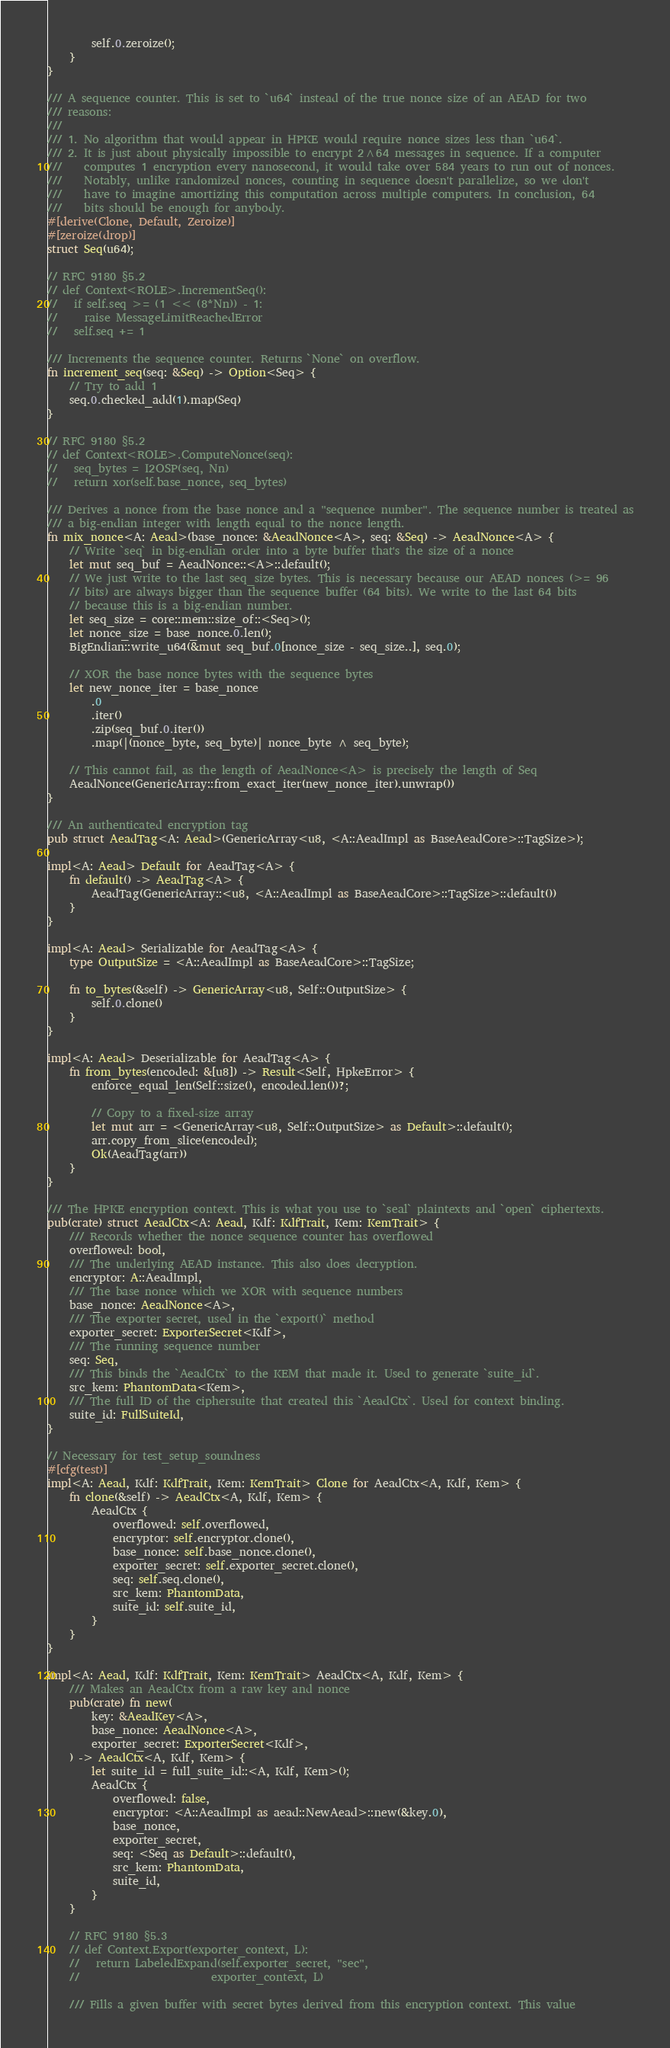<code> <loc_0><loc_0><loc_500><loc_500><_Rust_>        self.0.zeroize();
    }
}

/// A sequence counter. This is set to `u64` instead of the true nonce size of an AEAD for two
/// reasons:
///
/// 1. No algorithm that would appear in HPKE would require nonce sizes less than `u64`.
/// 2. It is just about physically impossible to encrypt 2^64 messages in sequence. If a computer
///    computes 1 encryption every nanosecond, it would take over 584 years to run out of nonces.
///    Notably, unlike randomized nonces, counting in sequence doesn't parallelize, so we don't
///    have to imagine amortizing this computation across multiple computers. In conclusion, 64
///    bits should be enough for anybody.
#[derive(Clone, Default, Zeroize)]
#[zeroize(drop)]
struct Seq(u64);

// RFC 9180 §5.2
// def Context<ROLE>.IncrementSeq():
//   if self.seq >= (1 << (8*Nn)) - 1:
//     raise MessageLimitReachedError
//   self.seq += 1

/// Increments the sequence counter. Returns `None` on overflow.
fn increment_seq(seq: &Seq) -> Option<Seq> {
    // Try to add 1
    seq.0.checked_add(1).map(Seq)
}

// RFC 9180 §5.2
// def Context<ROLE>.ComputeNonce(seq):
//   seq_bytes = I2OSP(seq, Nn)
//   return xor(self.base_nonce, seq_bytes)

/// Derives a nonce from the base nonce and a "sequence number". The sequence number is treated as
/// a big-endian integer with length equal to the nonce length.
fn mix_nonce<A: Aead>(base_nonce: &AeadNonce<A>, seq: &Seq) -> AeadNonce<A> {
    // Write `seq` in big-endian order into a byte buffer that's the size of a nonce
    let mut seq_buf = AeadNonce::<A>::default();
    // We just write to the last seq_size bytes. This is necessary because our AEAD nonces (>= 96
    // bits) are always bigger than the sequence buffer (64 bits). We write to the last 64 bits
    // because this is a big-endian number.
    let seq_size = core::mem::size_of::<Seq>();
    let nonce_size = base_nonce.0.len();
    BigEndian::write_u64(&mut seq_buf.0[nonce_size - seq_size..], seq.0);

    // XOR the base nonce bytes with the sequence bytes
    let new_nonce_iter = base_nonce
        .0
        .iter()
        .zip(seq_buf.0.iter())
        .map(|(nonce_byte, seq_byte)| nonce_byte ^ seq_byte);

    // This cannot fail, as the length of AeadNonce<A> is precisely the length of Seq
    AeadNonce(GenericArray::from_exact_iter(new_nonce_iter).unwrap())
}

/// An authenticated encryption tag
pub struct AeadTag<A: Aead>(GenericArray<u8, <A::AeadImpl as BaseAeadCore>::TagSize>);

impl<A: Aead> Default for AeadTag<A> {
    fn default() -> AeadTag<A> {
        AeadTag(GenericArray::<u8, <A::AeadImpl as BaseAeadCore>::TagSize>::default())
    }
}

impl<A: Aead> Serializable for AeadTag<A> {
    type OutputSize = <A::AeadImpl as BaseAeadCore>::TagSize;

    fn to_bytes(&self) -> GenericArray<u8, Self::OutputSize> {
        self.0.clone()
    }
}

impl<A: Aead> Deserializable for AeadTag<A> {
    fn from_bytes(encoded: &[u8]) -> Result<Self, HpkeError> {
        enforce_equal_len(Self::size(), encoded.len())?;

        // Copy to a fixed-size array
        let mut arr = <GenericArray<u8, Self::OutputSize> as Default>::default();
        arr.copy_from_slice(encoded);
        Ok(AeadTag(arr))
    }
}

/// The HPKE encryption context. This is what you use to `seal` plaintexts and `open` ciphertexts.
pub(crate) struct AeadCtx<A: Aead, Kdf: KdfTrait, Kem: KemTrait> {
    /// Records whether the nonce sequence counter has overflowed
    overflowed: bool,
    /// The underlying AEAD instance. This also does decryption.
    encryptor: A::AeadImpl,
    /// The base nonce which we XOR with sequence numbers
    base_nonce: AeadNonce<A>,
    /// The exporter secret, used in the `export()` method
    exporter_secret: ExporterSecret<Kdf>,
    /// The running sequence number
    seq: Seq,
    /// This binds the `AeadCtx` to the KEM that made it. Used to generate `suite_id`.
    src_kem: PhantomData<Kem>,
    /// The full ID of the ciphersuite that created this `AeadCtx`. Used for context binding.
    suite_id: FullSuiteId,
}

// Necessary for test_setup_soundness
#[cfg(test)]
impl<A: Aead, Kdf: KdfTrait, Kem: KemTrait> Clone for AeadCtx<A, Kdf, Kem> {
    fn clone(&self) -> AeadCtx<A, Kdf, Kem> {
        AeadCtx {
            overflowed: self.overflowed,
            encryptor: self.encryptor.clone(),
            base_nonce: self.base_nonce.clone(),
            exporter_secret: self.exporter_secret.clone(),
            seq: self.seq.clone(),
            src_kem: PhantomData,
            suite_id: self.suite_id,
        }
    }
}

impl<A: Aead, Kdf: KdfTrait, Kem: KemTrait> AeadCtx<A, Kdf, Kem> {
    /// Makes an AeadCtx from a raw key and nonce
    pub(crate) fn new(
        key: &AeadKey<A>,
        base_nonce: AeadNonce<A>,
        exporter_secret: ExporterSecret<Kdf>,
    ) -> AeadCtx<A, Kdf, Kem> {
        let suite_id = full_suite_id::<A, Kdf, Kem>();
        AeadCtx {
            overflowed: false,
            encryptor: <A::AeadImpl as aead::NewAead>::new(&key.0),
            base_nonce,
            exporter_secret,
            seq: <Seq as Default>::default(),
            src_kem: PhantomData,
            suite_id,
        }
    }

    // RFC 9180 §5.3
    // def Context.Export(exporter_context, L):
    //   return LabeledExpand(self.exporter_secret, "sec",
    //                        exporter_context, L)

    /// Fills a given buffer with secret bytes derived from this encryption context. This value</code> 